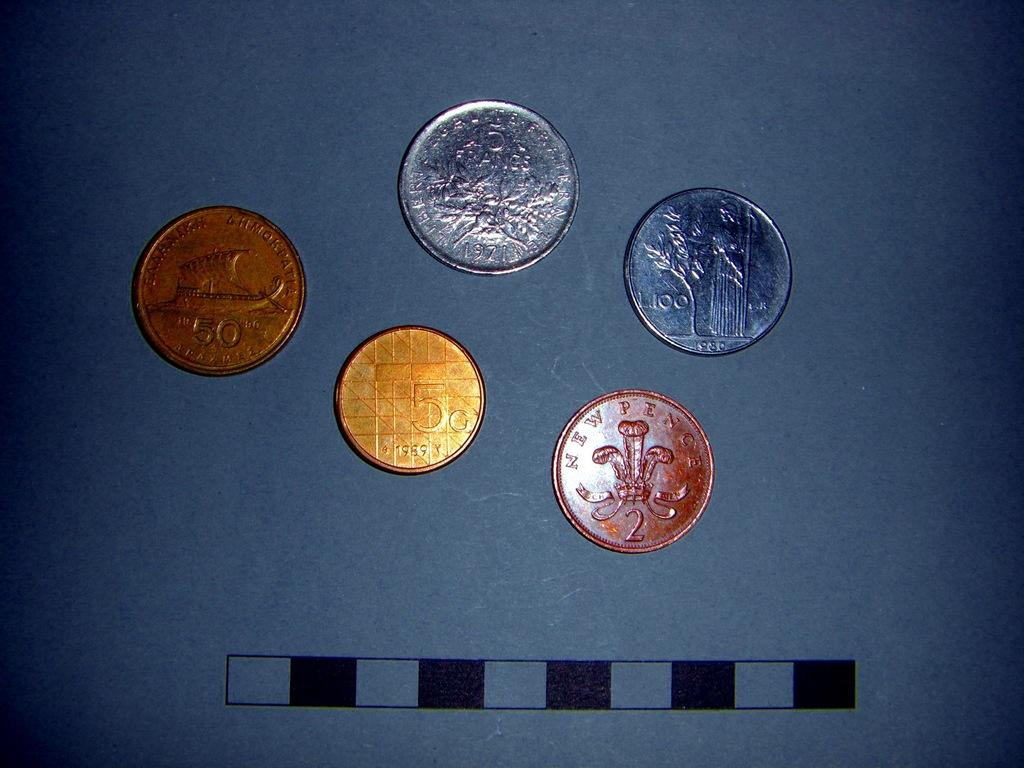<image>
Share a concise interpretation of the image provided. Five coins are lying next to each other and one says Newpence 